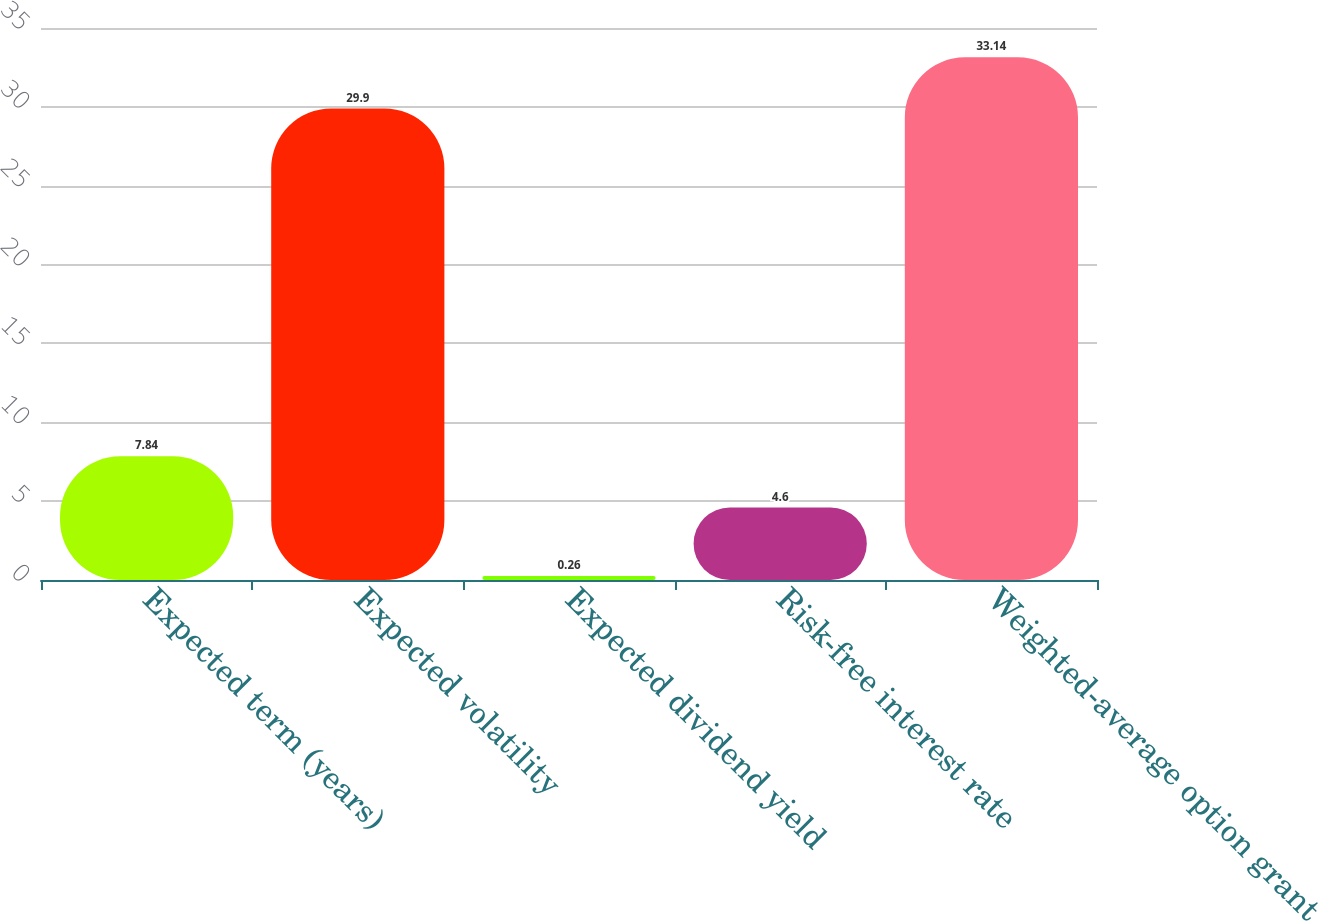Convert chart to OTSL. <chart><loc_0><loc_0><loc_500><loc_500><bar_chart><fcel>Expected term (years)<fcel>Expected volatility<fcel>Expected dividend yield<fcel>Risk-free interest rate<fcel>Weighted-average option grant<nl><fcel>7.84<fcel>29.9<fcel>0.26<fcel>4.6<fcel>33.14<nl></chart> 